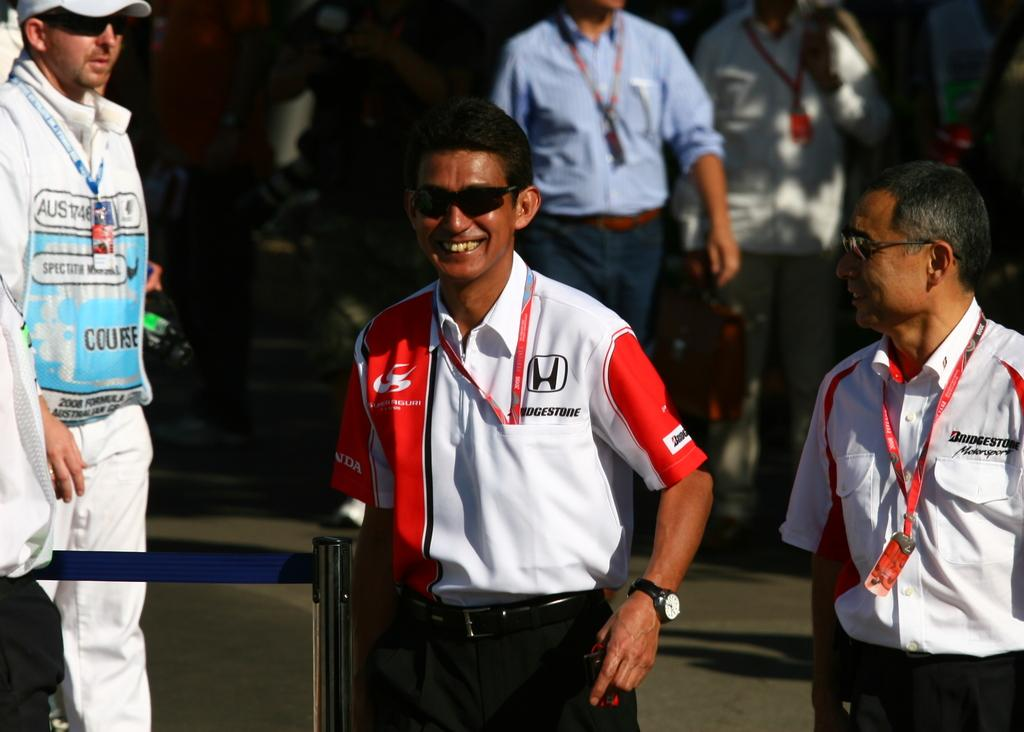<image>
Render a clear and concise summary of the photo. A man wearing a shirt with logos for Honda and Bridgestone is smiling. 